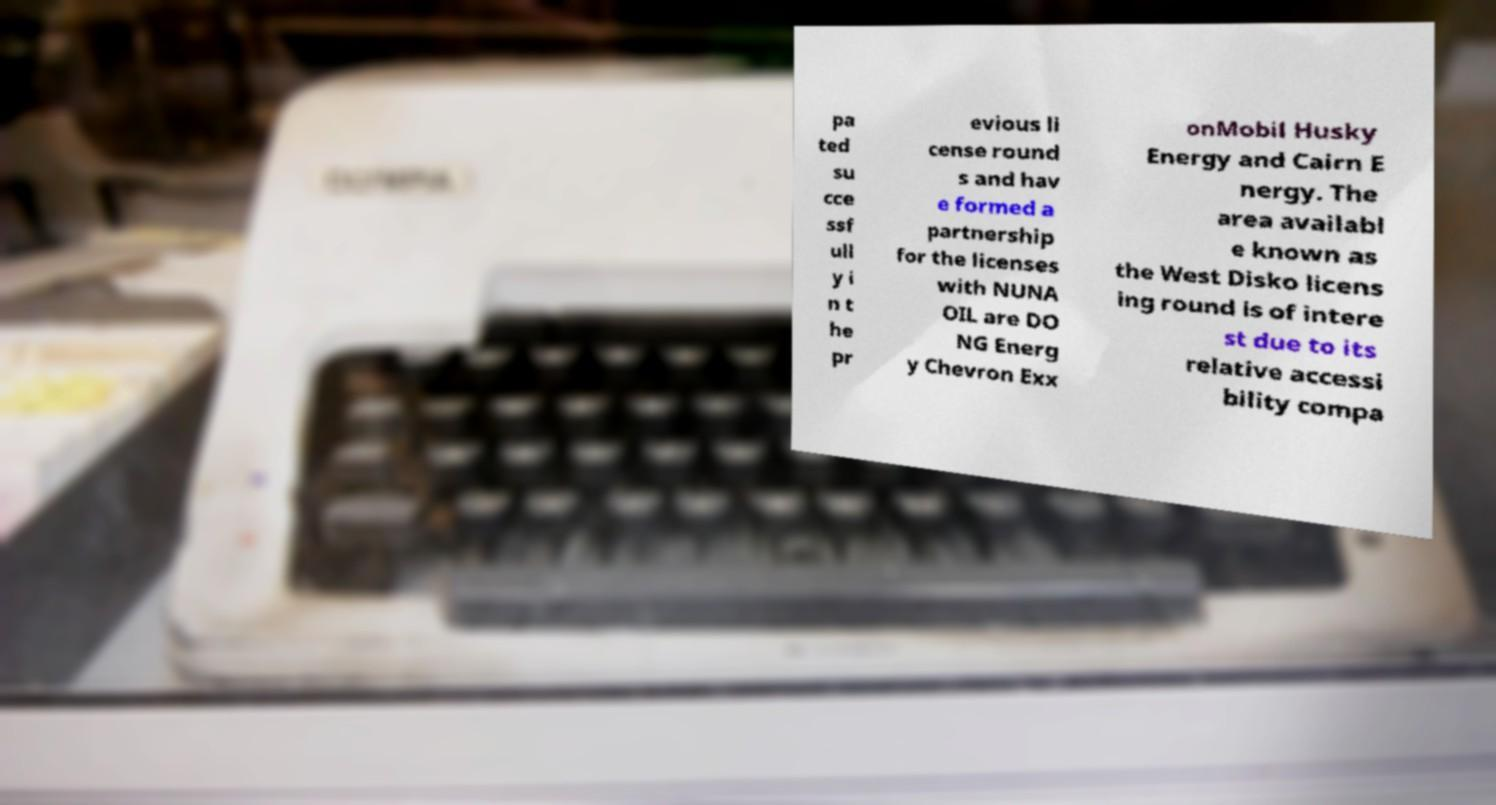Can you read and provide the text displayed in the image?This photo seems to have some interesting text. Can you extract and type it out for me? pa ted su cce ssf ull y i n t he pr evious li cense round s and hav e formed a partnership for the licenses with NUNA OIL are DO NG Energ y Chevron Exx onMobil Husky Energy and Cairn E nergy. The area availabl e known as the West Disko licens ing round is of intere st due to its relative accessi bility compa 